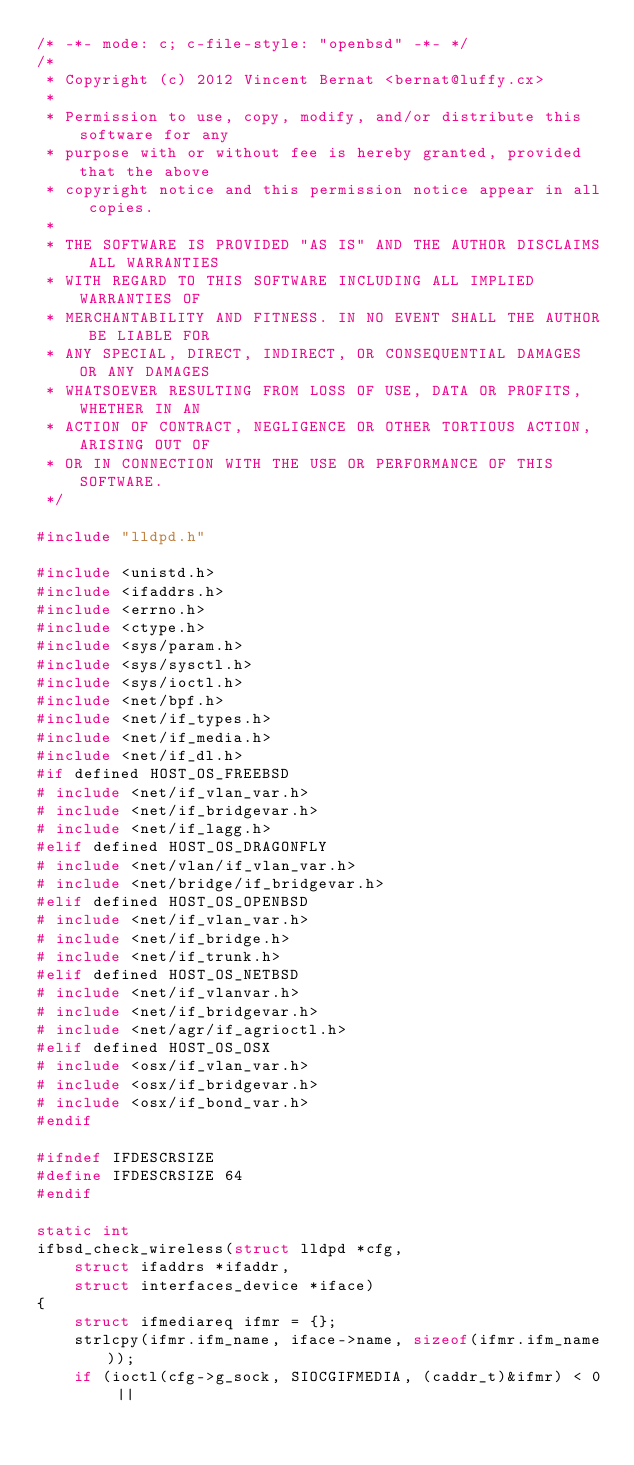<code> <loc_0><loc_0><loc_500><loc_500><_C_>/* -*- mode: c; c-file-style: "openbsd" -*- */
/*
 * Copyright (c) 2012 Vincent Bernat <bernat@luffy.cx>
 *
 * Permission to use, copy, modify, and/or distribute this software for any
 * purpose with or without fee is hereby granted, provided that the above
 * copyright notice and this permission notice appear in all copies.
 *
 * THE SOFTWARE IS PROVIDED "AS IS" AND THE AUTHOR DISCLAIMS ALL WARRANTIES
 * WITH REGARD TO THIS SOFTWARE INCLUDING ALL IMPLIED WARRANTIES OF
 * MERCHANTABILITY AND FITNESS. IN NO EVENT SHALL THE AUTHOR BE LIABLE FOR
 * ANY SPECIAL, DIRECT, INDIRECT, OR CONSEQUENTIAL DAMAGES OR ANY DAMAGES
 * WHATSOEVER RESULTING FROM LOSS OF USE, DATA OR PROFITS, WHETHER IN AN
 * ACTION OF CONTRACT, NEGLIGENCE OR OTHER TORTIOUS ACTION, ARISING OUT OF
 * OR IN CONNECTION WITH THE USE OR PERFORMANCE OF THIS SOFTWARE.
 */

#include "lldpd.h"

#include <unistd.h>
#include <ifaddrs.h>
#include <errno.h>
#include <ctype.h>
#include <sys/param.h>
#include <sys/sysctl.h>
#include <sys/ioctl.h>
#include <net/bpf.h>
#include <net/if_types.h>
#include <net/if_media.h>
#include <net/if_dl.h>
#if defined HOST_OS_FREEBSD
# include <net/if_vlan_var.h>
# include <net/if_bridgevar.h>
# include <net/if_lagg.h>
#elif defined HOST_OS_DRAGONFLY
# include <net/vlan/if_vlan_var.h>
# include <net/bridge/if_bridgevar.h>
#elif defined HOST_OS_OPENBSD
# include <net/if_vlan_var.h>
# include <net/if_bridge.h>
# include <net/if_trunk.h>
#elif defined HOST_OS_NETBSD
# include <net/if_vlanvar.h>
# include <net/if_bridgevar.h>
# include <net/agr/if_agrioctl.h>
#elif defined HOST_OS_OSX
# include <osx/if_vlan_var.h>
# include <osx/if_bridgevar.h>
# include <osx/if_bond_var.h>
#endif

#ifndef IFDESCRSIZE
#define IFDESCRSIZE 64
#endif

static int
ifbsd_check_wireless(struct lldpd *cfg,
    struct ifaddrs *ifaddr,
    struct interfaces_device *iface)
{
    struct ifmediareq ifmr = {};
    strlcpy(ifmr.ifm_name, iface->name, sizeof(ifmr.ifm_name));
    if (ioctl(cfg->g_sock, SIOCGIFMEDIA, (caddr_t)&ifmr) < 0 ||</code> 